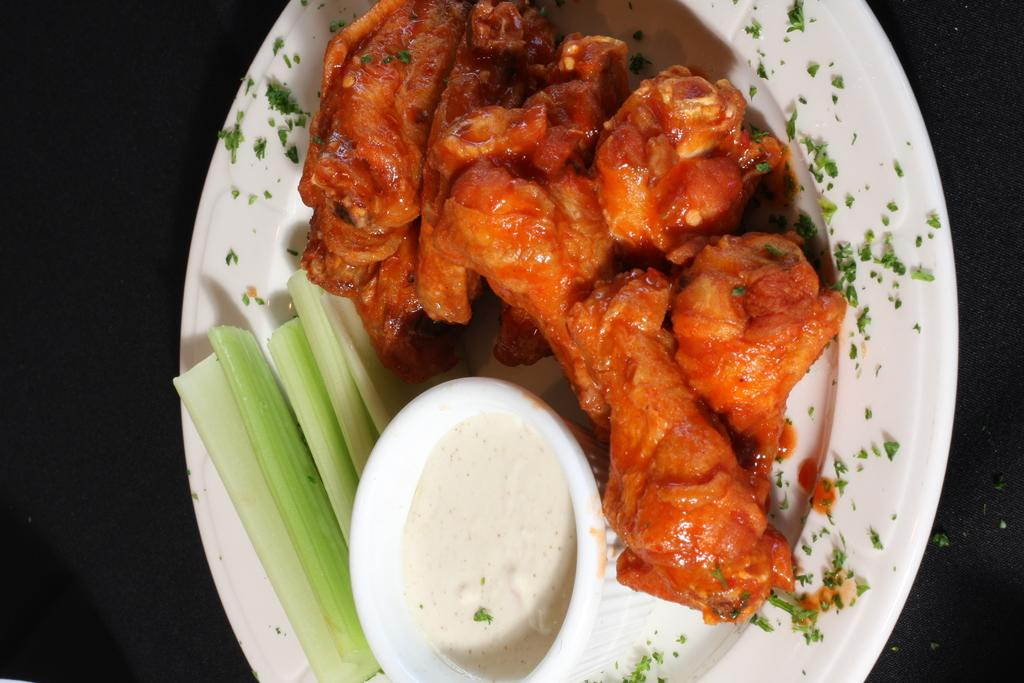What type of food can be seen in the image? The food in the image has red, green, and white colors. What color is the plate that the food is on? The plate is white. How would you describe the background of the image? The background of the image is dark. Can you see a gun in the image? No, there is no gun present in the image. What type of zephyr is depicted in the image? There is no zephyr depicted in the image; it features food on a white plate with a dark background. 